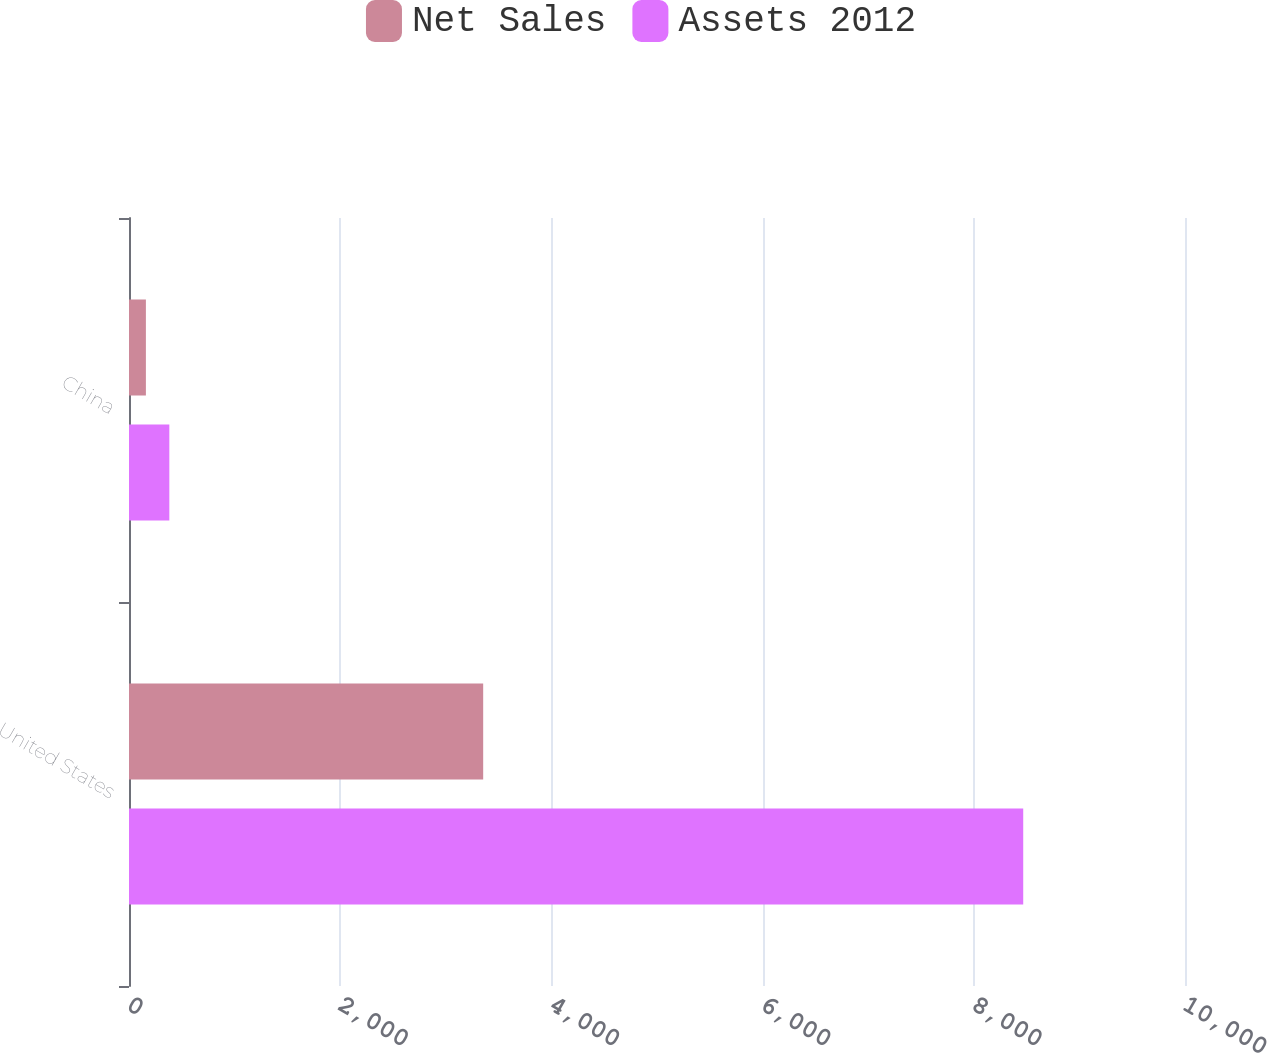Convert chart. <chart><loc_0><loc_0><loc_500><loc_500><stacked_bar_chart><ecel><fcel>United States<fcel>China<nl><fcel>Net Sales<fcel>3354<fcel>160<nl><fcel>Assets 2012<fcel>8468<fcel>382<nl></chart> 